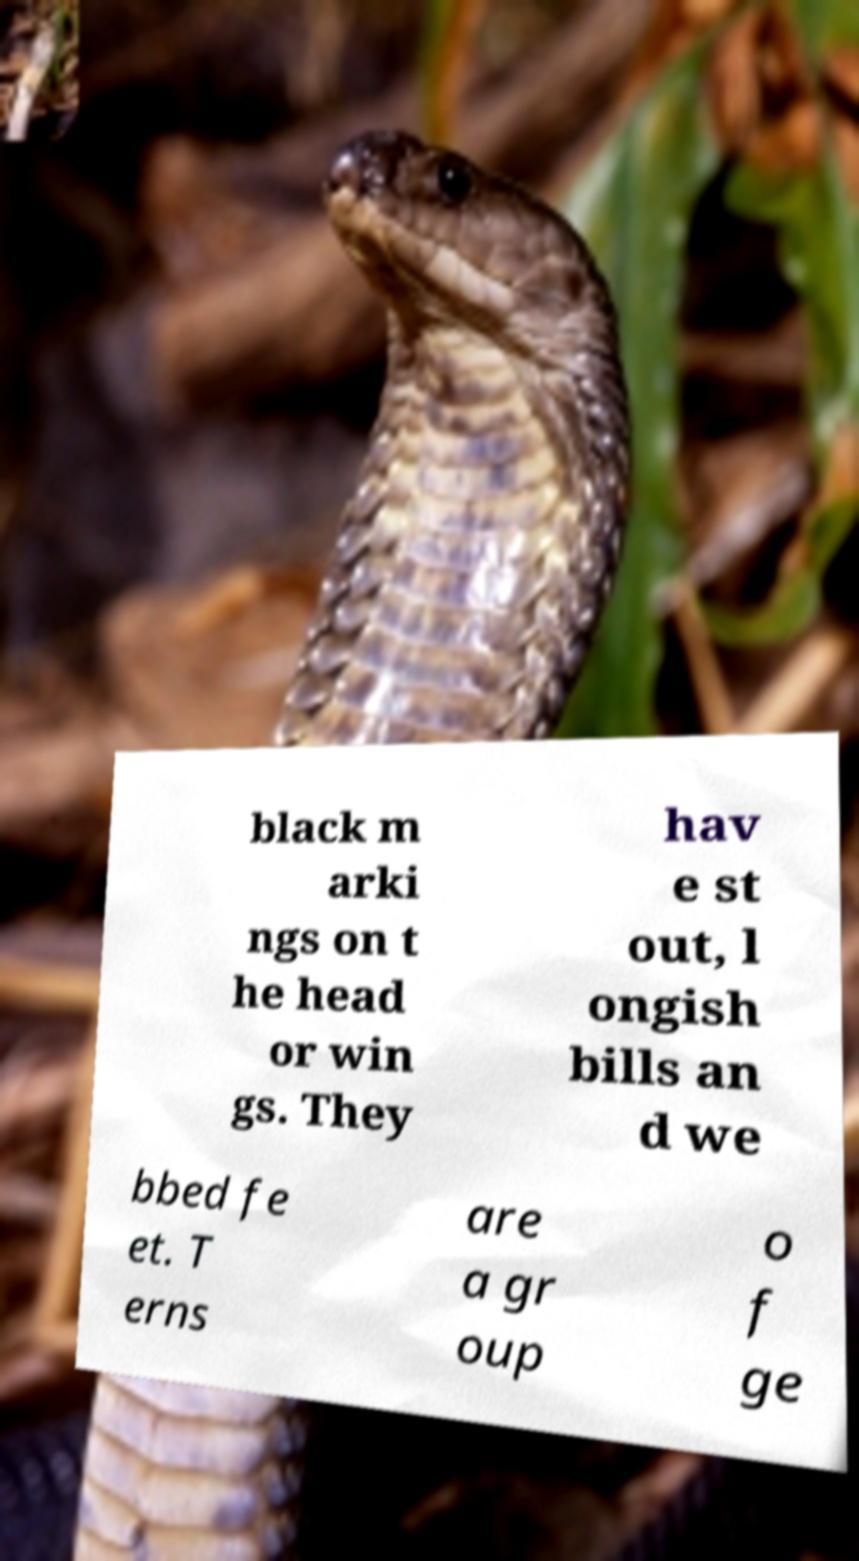For documentation purposes, I need the text within this image transcribed. Could you provide that? black m arki ngs on t he head or win gs. They hav e st out, l ongish bills an d we bbed fe et. T erns are a gr oup o f ge 